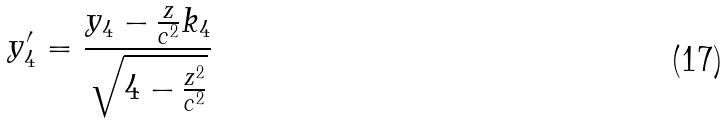Convert formula to latex. <formula><loc_0><loc_0><loc_500><loc_500>y _ { 4 } ^ { \prime } = \frac { y _ { 4 } - \frac { z } { c ^ { 2 } } k _ { 4 } } { \sqrt { 4 - \frac { z ^ { 2 } } { c ^ { 2 } } } }</formula> 